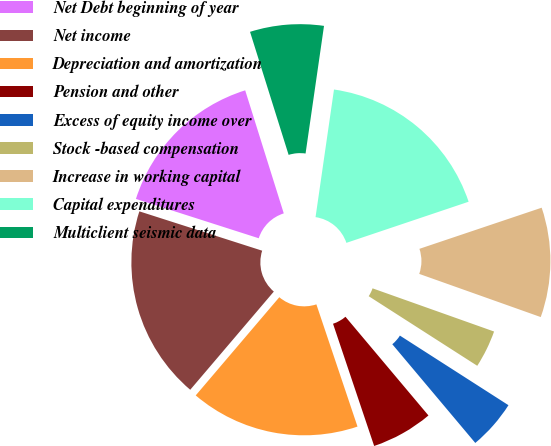<chart> <loc_0><loc_0><loc_500><loc_500><pie_chart><fcel>Net Debt beginning of year<fcel>Net income<fcel>Depreciation and amortization<fcel>Pension and other<fcel>Excess of equity income over<fcel>Stock -based compensation<fcel>Increase in working capital<fcel>Capital expenditures<fcel>Multiclient seismic data<nl><fcel>15.23%<fcel>18.71%<fcel>16.39%<fcel>5.96%<fcel>4.8%<fcel>3.64%<fcel>10.6%<fcel>17.55%<fcel>7.12%<nl></chart> 